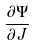<formula> <loc_0><loc_0><loc_500><loc_500>\frac { \partial \Psi } { \partial J }</formula> 